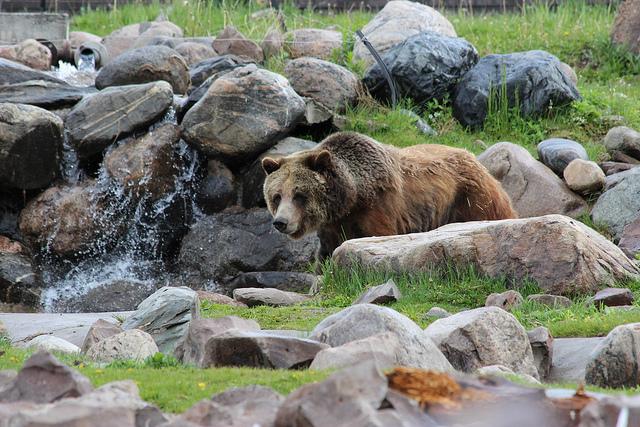Are the rocks wet?
Short answer required. Yes. What color is the bear?
Concise answer only. Brown. Which way is the bear walking, to the left or to the right?
Answer briefly. Left. 